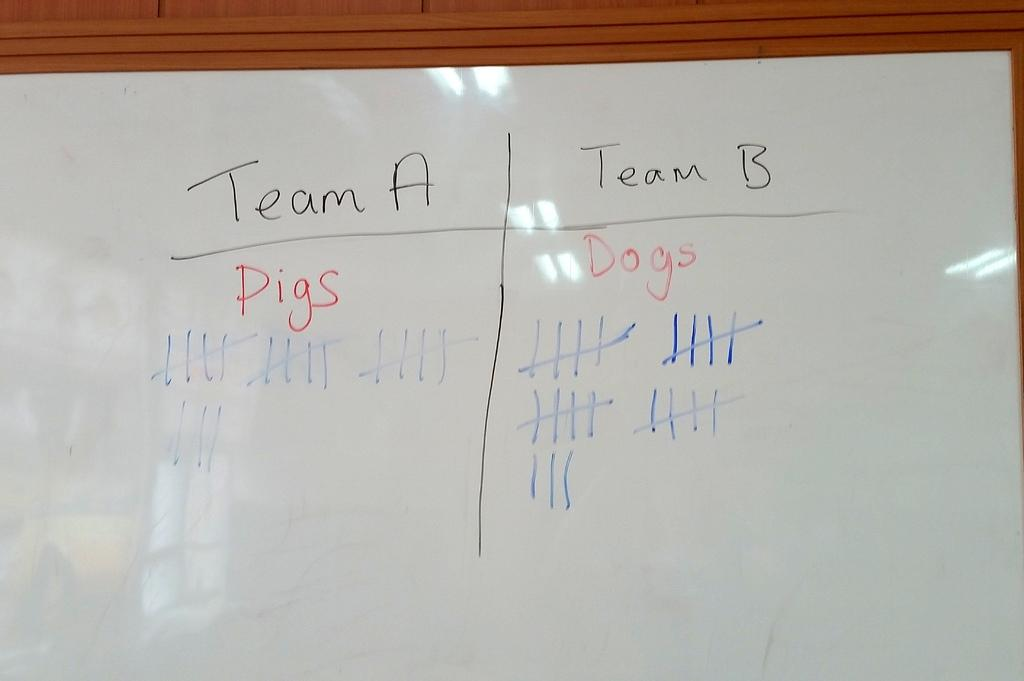<image>
Give a short and clear explanation of the subsequent image. a white board with Team A and Team B with tally marks 